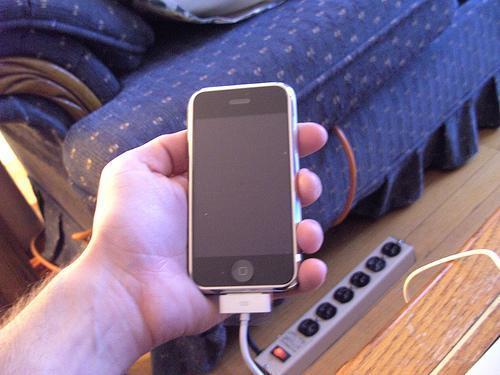How many phones are visible in this photo?
Give a very brief answer. 1. How many hands are visibly holding a phone in this photo?
Give a very brief answer. 1. 